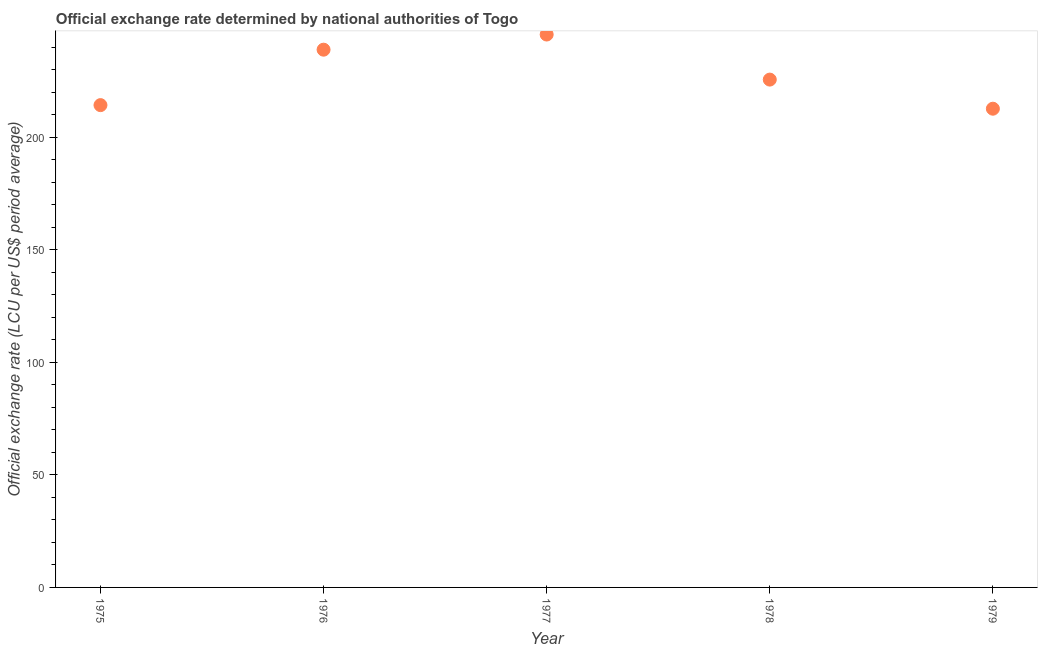What is the official exchange rate in 1979?
Make the answer very short. 212.72. Across all years, what is the maximum official exchange rate?
Keep it short and to the point. 245.68. Across all years, what is the minimum official exchange rate?
Offer a terse response. 212.72. In which year was the official exchange rate minimum?
Offer a very short reply. 1979. What is the sum of the official exchange rate?
Your response must be concise. 1137.32. What is the difference between the official exchange rate in 1975 and 1979?
Offer a terse response. 1.59. What is the average official exchange rate per year?
Your answer should be very brief. 227.46. What is the median official exchange rate?
Offer a terse response. 225.66. In how many years, is the official exchange rate greater than 50 ?
Make the answer very short. 5. What is the ratio of the official exchange rate in 1977 to that in 1978?
Your response must be concise. 1.09. What is the difference between the highest and the second highest official exchange rate?
Give a very brief answer. 6.73. What is the difference between the highest and the lowest official exchange rate?
Make the answer very short. 32.96. How many years are there in the graph?
Your answer should be very brief. 5. Are the values on the major ticks of Y-axis written in scientific E-notation?
Provide a succinct answer. No. Does the graph contain any zero values?
Make the answer very short. No. Does the graph contain grids?
Make the answer very short. No. What is the title of the graph?
Provide a short and direct response. Official exchange rate determined by national authorities of Togo. What is the label or title of the X-axis?
Provide a short and direct response. Year. What is the label or title of the Y-axis?
Make the answer very short. Official exchange rate (LCU per US$ period average). What is the Official exchange rate (LCU per US$ period average) in 1975?
Offer a very short reply. 214.31. What is the Official exchange rate (LCU per US$ period average) in 1976?
Your answer should be very brief. 238.95. What is the Official exchange rate (LCU per US$ period average) in 1977?
Offer a very short reply. 245.68. What is the Official exchange rate (LCU per US$ period average) in 1978?
Make the answer very short. 225.66. What is the Official exchange rate (LCU per US$ period average) in 1979?
Your response must be concise. 212.72. What is the difference between the Official exchange rate (LCU per US$ period average) in 1975 and 1976?
Offer a terse response. -24.64. What is the difference between the Official exchange rate (LCU per US$ period average) in 1975 and 1977?
Your response must be concise. -31.37. What is the difference between the Official exchange rate (LCU per US$ period average) in 1975 and 1978?
Provide a succinct answer. -11.34. What is the difference between the Official exchange rate (LCU per US$ period average) in 1975 and 1979?
Make the answer very short. 1.59. What is the difference between the Official exchange rate (LCU per US$ period average) in 1976 and 1977?
Ensure brevity in your answer.  -6.73. What is the difference between the Official exchange rate (LCU per US$ period average) in 1976 and 1978?
Your answer should be compact. 13.29. What is the difference between the Official exchange rate (LCU per US$ period average) in 1976 and 1979?
Give a very brief answer. 26.23. What is the difference between the Official exchange rate (LCU per US$ period average) in 1977 and 1978?
Offer a terse response. 20.02. What is the difference between the Official exchange rate (LCU per US$ period average) in 1977 and 1979?
Your answer should be compact. 32.96. What is the difference between the Official exchange rate (LCU per US$ period average) in 1978 and 1979?
Keep it short and to the point. 12.93. What is the ratio of the Official exchange rate (LCU per US$ period average) in 1975 to that in 1976?
Offer a very short reply. 0.9. What is the ratio of the Official exchange rate (LCU per US$ period average) in 1975 to that in 1977?
Your answer should be very brief. 0.87. What is the ratio of the Official exchange rate (LCU per US$ period average) in 1975 to that in 1978?
Your answer should be very brief. 0.95. What is the ratio of the Official exchange rate (LCU per US$ period average) in 1975 to that in 1979?
Your answer should be very brief. 1.01. What is the ratio of the Official exchange rate (LCU per US$ period average) in 1976 to that in 1977?
Ensure brevity in your answer.  0.97. What is the ratio of the Official exchange rate (LCU per US$ period average) in 1976 to that in 1978?
Give a very brief answer. 1.06. What is the ratio of the Official exchange rate (LCU per US$ period average) in 1976 to that in 1979?
Your answer should be very brief. 1.12. What is the ratio of the Official exchange rate (LCU per US$ period average) in 1977 to that in 1978?
Your response must be concise. 1.09. What is the ratio of the Official exchange rate (LCU per US$ period average) in 1977 to that in 1979?
Offer a very short reply. 1.16. What is the ratio of the Official exchange rate (LCU per US$ period average) in 1978 to that in 1979?
Provide a short and direct response. 1.06. 